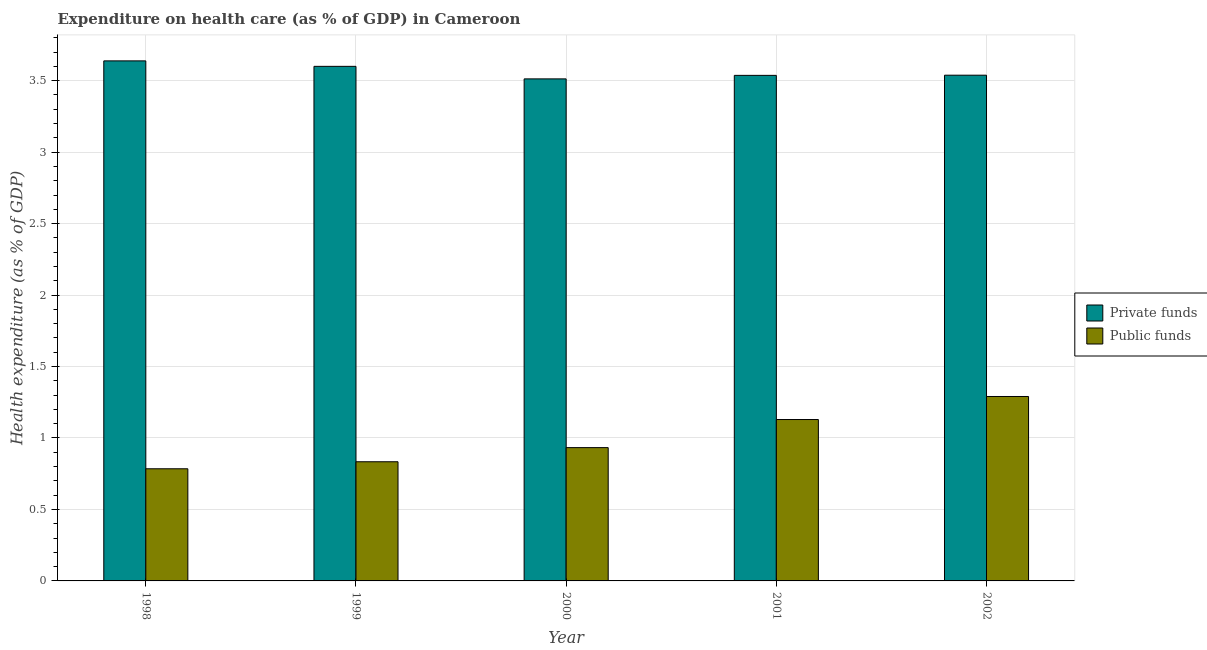How many different coloured bars are there?
Your answer should be very brief. 2. Are the number of bars per tick equal to the number of legend labels?
Your answer should be compact. Yes. How many bars are there on the 5th tick from the left?
Your answer should be compact. 2. What is the amount of private funds spent in healthcare in 2002?
Offer a very short reply. 3.54. Across all years, what is the maximum amount of private funds spent in healthcare?
Your answer should be compact. 3.64. Across all years, what is the minimum amount of public funds spent in healthcare?
Provide a short and direct response. 0.78. In which year was the amount of private funds spent in healthcare maximum?
Offer a terse response. 1998. In which year was the amount of public funds spent in healthcare minimum?
Your answer should be compact. 1998. What is the total amount of private funds spent in healthcare in the graph?
Make the answer very short. 17.83. What is the difference between the amount of public funds spent in healthcare in 2001 and that in 2002?
Your answer should be compact. -0.16. What is the difference between the amount of public funds spent in healthcare in 2000 and the amount of private funds spent in healthcare in 2002?
Make the answer very short. -0.36. What is the average amount of public funds spent in healthcare per year?
Make the answer very short. 0.99. In the year 2002, what is the difference between the amount of private funds spent in healthcare and amount of public funds spent in healthcare?
Your response must be concise. 0. What is the ratio of the amount of private funds spent in healthcare in 1999 to that in 2001?
Make the answer very short. 1.02. What is the difference between the highest and the second highest amount of private funds spent in healthcare?
Your response must be concise. 0.04. What is the difference between the highest and the lowest amount of private funds spent in healthcare?
Keep it short and to the point. 0.13. In how many years, is the amount of public funds spent in healthcare greater than the average amount of public funds spent in healthcare taken over all years?
Your answer should be compact. 2. What does the 1st bar from the left in 2000 represents?
Ensure brevity in your answer.  Private funds. What does the 2nd bar from the right in 1999 represents?
Your response must be concise. Private funds. How many bars are there?
Offer a very short reply. 10. Are all the bars in the graph horizontal?
Keep it short and to the point. No. How many years are there in the graph?
Provide a succinct answer. 5. What is the difference between two consecutive major ticks on the Y-axis?
Ensure brevity in your answer.  0.5. Does the graph contain any zero values?
Provide a succinct answer. No. Does the graph contain grids?
Provide a short and direct response. Yes. What is the title of the graph?
Provide a short and direct response. Expenditure on health care (as % of GDP) in Cameroon. Does "Commercial service exports" appear as one of the legend labels in the graph?
Offer a very short reply. No. What is the label or title of the Y-axis?
Offer a terse response. Health expenditure (as % of GDP). What is the Health expenditure (as % of GDP) in Private funds in 1998?
Your answer should be compact. 3.64. What is the Health expenditure (as % of GDP) of Public funds in 1998?
Your answer should be compact. 0.78. What is the Health expenditure (as % of GDP) of Private funds in 1999?
Your answer should be compact. 3.6. What is the Health expenditure (as % of GDP) of Public funds in 1999?
Your response must be concise. 0.83. What is the Health expenditure (as % of GDP) in Private funds in 2000?
Give a very brief answer. 3.51. What is the Health expenditure (as % of GDP) in Public funds in 2000?
Your response must be concise. 0.93. What is the Health expenditure (as % of GDP) of Private funds in 2001?
Offer a very short reply. 3.54. What is the Health expenditure (as % of GDP) in Public funds in 2001?
Keep it short and to the point. 1.13. What is the Health expenditure (as % of GDP) in Private funds in 2002?
Ensure brevity in your answer.  3.54. What is the Health expenditure (as % of GDP) in Public funds in 2002?
Make the answer very short. 1.29. Across all years, what is the maximum Health expenditure (as % of GDP) in Private funds?
Give a very brief answer. 3.64. Across all years, what is the maximum Health expenditure (as % of GDP) in Public funds?
Your answer should be very brief. 1.29. Across all years, what is the minimum Health expenditure (as % of GDP) of Private funds?
Offer a very short reply. 3.51. Across all years, what is the minimum Health expenditure (as % of GDP) in Public funds?
Provide a short and direct response. 0.78. What is the total Health expenditure (as % of GDP) in Private funds in the graph?
Your answer should be very brief. 17.83. What is the total Health expenditure (as % of GDP) of Public funds in the graph?
Offer a terse response. 4.97. What is the difference between the Health expenditure (as % of GDP) in Private funds in 1998 and that in 1999?
Keep it short and to the point. 0.04. What is the difference between the Health expenditure (as % of GDP) of Public funds in 1998 and that in 1999?
Provide a succinct answer. -0.05. What is the difference between the Health expenditure (as % of GDP) in Private funds in 1998 and that in 2000?
Keep it short and to the point. 0.13. What is the difference between the Health expenditure (as % of GDP) of Public funds in 1998 and that in 2000?
Keep it short and to the point. -0.15. What is the difference between the Health expenditure (as % of GDP) of Private funds in 1998 and that in 2001?
Keep it short and to the point. 0.1. What is the difference between the Health expenditure (as % of GDP) of Public funds in 1998 and that in 2001?
Offer a terse response. -0.34. What is the difference between the Health expenditure (as % of GDP) of Private funds in 1998 and that in 2002?
Offer a terse response. 0.1. What is the difference between the Health expenditure (as % of GDP) in Public funds in 1998 and that in 2002?
Offer a very short reply. -0.51. What is the difference between the Health expenditure (as % of GDP) of Private funds in 1999 and that in 2000?
Give a very brief answer. 0.09. What is the difference between the Health expenditure (as % of GDP) in Public funds in 1999 and that in 2000?
Your response must be concise. -0.1. What is the difference between the Health expenditure (as % of GDP) in Private funds in 1999 and that in 2001?
Provide a short and direct response. 0.06. What is the difference between the Health expenditure (as % of GDP) in Public funds in 1999 and that in 2001?
Your response must be concise. -0.3. What is the difference between the Health expenditure (as % of GDP) in Private funds in 1999 and that in 2002?
Your answer should be compact. 0.06. What is the difference between the Health expenditure (as % of GDP) in Public funds in 1999 and that in 2002?
Ensure brevity in your answer.  -0.46. What is the difference between the Health expenditure (as % of GDP) of Private funds in 2000 and that in 2001?
Make the answer very short. -0.02. What is the difference between the Health expenditure (as % of GDP) of Public funds in 2000 and that in 2001?
Give a very brief answer. -0.2. What is the difference between the Health expenditure (as % of GDP) of Private funds in 2000 and that in 2002?
Your response must be concise. -0.03. What is the difference between the Health expenditure (as % of GDP) in Public funds in 2000 and that in 2002?
Your answer should be compact. -0.36. What is the difference between the Health expenditure (as % of GDP) in Private funds in 2001 and that in 2002?
Provide a succinct answer. -0. What is the difference between the Health expenditure (as % of GDP) of Public funds in 2001 and that in 2002?
Make the answer very short. -0.16. What is the difference between the Health expenditure (as % of GDP) of Private funds in 1998 and the Health expenditure (as % of GDP) of Public funds in 1999?
Keep it short and to the point. 2.8. What is the difference between the Health expenditure (as % of GDP) of Private funds in 1998 and the Health expenditure (as % of GDP) of Public funds in 2000?
Ensure brevity in your answer.  2.71. What is the difference between the Health expenditure (as % of GDP) in Private funds in 1998 and the Health expenditure (as % of GDP) in Public funds in 2001?
Keep it short and to the point. 2.51. What is the difference between the Health expenditure (as % of GDP) of Private funds in 1998 and the Health expenditure (as % of GDP) of Public funds in 2002?
Provide a succinct answer. 2.35. What is the difference between the Health expenditure (as % of GDP) of Private funds in 1999 and the Health expenditure (as % of GDP) of Public funds in 2000?
Keep it short and to the point. 2.67. What is the difference between the Health expenditure (as % of GDP) of Private funds in 1999 and the Health expenditure (as % of GDP) of Public funds in 2001?
Make the answer very short. 2.47. What is the difference between the Health expenditure (as % of GDP) in Private funds in 1999 and the Health expenditure (as % of GDP) in Public funds in 2002?
Make the answer very short. 2.31. What is the difference between the Health expenditure (as % of GDP) of Private funds in 2000 and the Health expenditure (as % of GDP) of Public funds in 2001?
Provide a short and direct response. 2.38. What is the difference between the Health expenditure (as % of GDP) in Private funds in 2000 and the Health expenditure (as % of GDP) in Public funds in 2002?
Your answer should be very brief. 2.22. What is the difference between the Health expenditure (as % of GDP) of Private funds in 2001 and the Health expenditure (as % of GDP) of Public funds in 2002?
Your answer should be very brief. 2.25. What is the average Health expenditure (as % of GDP) in Private funds per year?
Offer a very short reply. 3.57. In the year 1998, what is the difference between the Health expenditure (as % of GDP) of Private funds and Health expenditure (as % of GDP) of Public funds?
Your response must be concise. 2.85. In the year 1999, what is the difference between the Health expenditure (as % of GDP) in Private funds and Health expenditure (as % of GDP) in Public funds?
Your response must be concise. 2.77. In the year 2000, what is the difference between the Health expenditure (as % of GDP) of Private funds and Health expenditure (as % of GDP) of Public funds?
Keep it short and to the point. 2.58. In the year 2001, what is the difference between the Health expenditure (as % of GDP) of Private funds and Health expenditure (as % of GDP) of Public funds?
Your response must be concise. 2.41. In the year 2002, what is the difference between the Health expenditure (as % of GDP) in Private funds and Health expenditure (as % of GDP) in Public funds?
Your response must be concise. 2.25. What is the ratio of the Health expenditure (as % of GDP) of Private funds in 1998 to that in 1999?
Give a very brief answer. 1.01. What is the ratio of the Health expenditure (as % of GDP) of Public funds in 1998 to that in 1999?
Your answer should be compact. 0.94. What is the ratio of the Health expenditure (as % of GDP) of Private funds in 1998 to that in 2000?
Provide a short and direct response. 1.04. What is the ratio of the Health expenditure (as % of GDP) in Public funds in 1998 to that in 2000?
Offer a very short reply. 0.84. What is the ratio of the Health expenditure (as % of GDP) of Private funds in 1998 to that in 2001?
Give a very brief answer. 1.03. What is the ratio of the Health expenditure (as % of GDP) in Public funds in 1998 to that in 2001?
Your answer should be very brief. 0.69. What is the ratio of the Health expenditure (as % of GDP) in Private funds in 1998 to that in 2002?
Ensure brevity in your answer.  1.03. What is the ratio of the Health expenditure (as % of GDP) of Public funds in 1998 to that in 2002?
Make the answer very short. 0.61. What is the ratio of the Health expenditure (as % of GDP) in Public funds in 1999 to that in 2000?
Your response must be concise. 0.89. What is the ratio of the Health expenditure (as % of GDP) of Private funds in 1999 to that in 2001?
Your response must be concise. 1.02. What is the ratio of the Health expenditure (as % of GDP) in Public funds in 1999 to that in 2001?
Your answer should be compact. 0.74. What is the ratio of the Health expenditure (as % of GDP) of Private funds in 1999 to that in 2002?
Provide a succinct answer. 1.02. What is the ratio of the Health expenditure (as % of GDP) in Public funds in 1999 to that in 2002?
Provide a short and direct response. 0.65. What is the ratio of the Health expenditure (as % of GDP) of Private funds in 2000 to that in 2001?
Offer a very short reply. 0.99. What is the ratio of the Health expenditure (as % of GDP) of Public funds in 2000 to that in 2001?
Your answer should be very brief. 0.83. What is the ratio of the Health expenditure (as % of GDP) in Private funds in 2000 to that in 2002?
Make the answer very short. 0.99. What is the ratio of the Health expenditure (as % of GDP) in Public funds in 2000 to that in 2002?
Your response must be concise. 0.72. What is the ratio of the Health expenditure (as % of GDP) of Public funds in 2001 to that in 2002?
Offer a terse response. 0.88. What is the difference between the highest and the second highest Health expenditure (as % of GDP) of Private funds?
Offer a very short reply. 0.04. What is the difference between the highest and the second highest Health expenditure (as % of GDP) of Public funds?
Offer a very short reply. 0.16. What is the difference between the highest and the lowest Health expenditure (as % of GDP) in Private funds?
Keep it short and to the point. 0.13. What is the difference between the highest and the lowest Health expenditure (as % of GDP) in Public funds?
Your answer should be compact. 0.51. 